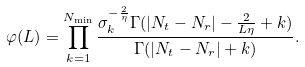Convert formula to latex. <formula><loc_0><loc_0><loc_500><loc_500>\varphi ( L ) = \prod _ { k = 1 } ^ { N _ { \min } } \frac { \sigma _ { k } ^ { - \frac { 2 } { \eta } } \Gamma ( | N _ { t } - N _ { r } | - \frac { 2 } { L \eta } + k ) } { \Gamma ( | N _ { t } - N _ { r } | + k ) } .</formula> 